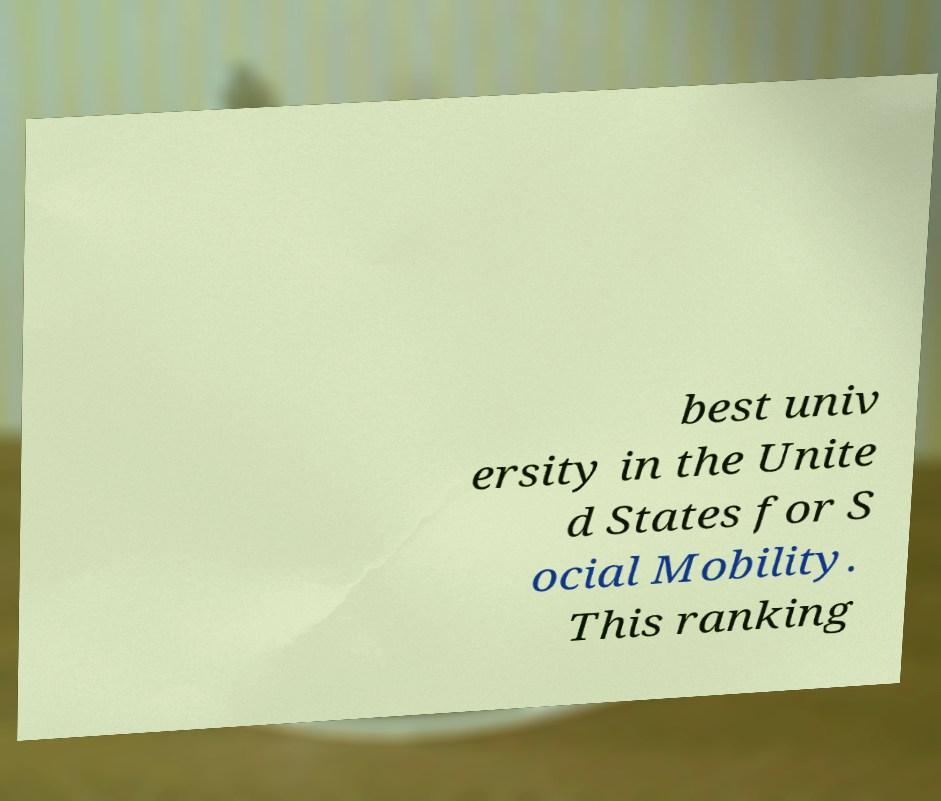Can you accurately transcribe the text from the provided image for me? best univ ersity in the Unite d States for S ocial Mobility. This ranking 